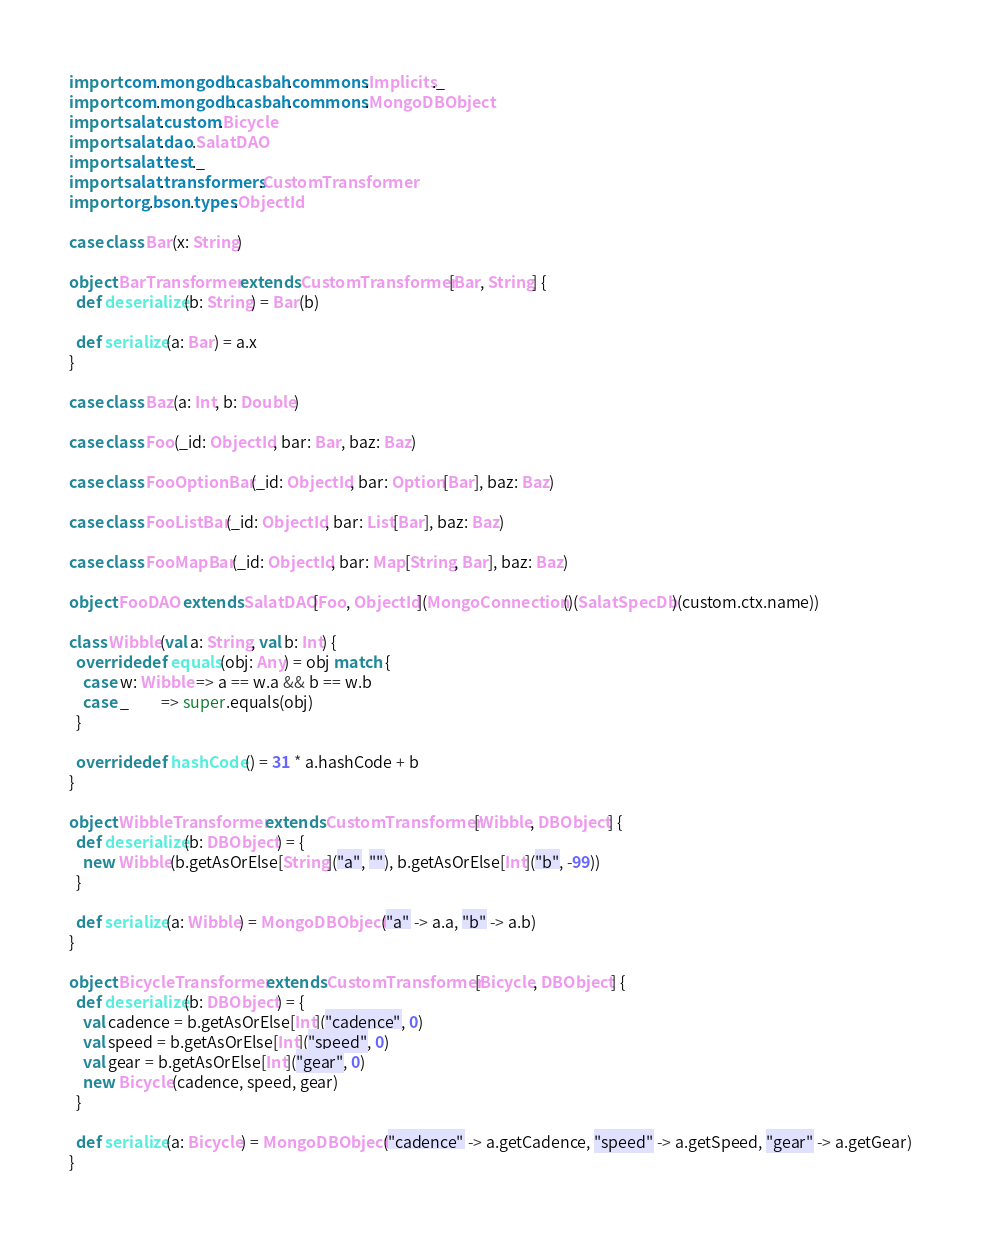Convert code to text. <code><loc_0><loc_0><loc_500><loc_500><_Scala_>import com.mongodb.casbah.commons.Implicits._
import com.mongodb.casbah.commons.MongoDBObject
import salat.custom.Bicycle
import salat.dao.SalatDAO
import salat.test._
import salat.transformers.CustomTransformer
import org.bson.types.ObjectId

case class Bar(x: String)

object BarTransformer extends CustomTransformer[Bar, String] {
  def deserialize(b: String) = Bar(b)

  def serialize(a: Bar) = a.x
}

case class Baz(a: Int, b: Double)

case class Foo(_id: ObjectId, bar: Bar, baz: Baz)

case class FooOptionBar(_id: ObjectId, bar: Option[Bar], baz: Baz)

case class FooListBar(_id: ObjectId, bar: List[Bar], baz: Baz)

case class FooMapBar(_id: ObjectId, bar: Map[String, Bar], baz: Baz)

object FooDAO extends SalatDAO[Foo, ObjectId](MongoConnection()(SalatSpecDb)(custom.ctx.name))

class Wibble(val a: String, val b: Int) {
  override def equals(obj: Any) = obj match {
    case w: Wibble => a == w.a && b == w.b
    case _         => super.equals(obj)
  }

  override def hashCode() = 31 * a.hashCode + b
}

object WibbleTransformer extends CustomTransformer[Wibble, DBObject] {
  def deserialize(b: DBObject) = {
    new Wibble(b.getAsOrElse[String]("a", ""), b.getAsOrElse[Int]("b", -99))
  }

  def serialize(a: Wibble) = MongoDBObject("a" -> a.a, "b" -> a.b)
}

object BicycleTransformer extends CustomTransformer[Bicycle, DBObject] {
  def deserialize(b: DBObject) = {
    val cadence = b.getAsOrElse[Int]("cadence", 0)
    val speed = b.getAsOrElse[Int]("speed", 0)
    val gear = b.getAsOrElse[Int]("gear", 0)
    new Bicycle(cadence, speed, gear)
  }

  def serialize(a: Bicycle) = MongoDBObject("cadence" -> a.getCadence, "speed" -> a.getSpeed, "gear" -> a.getGear)
}</code> 